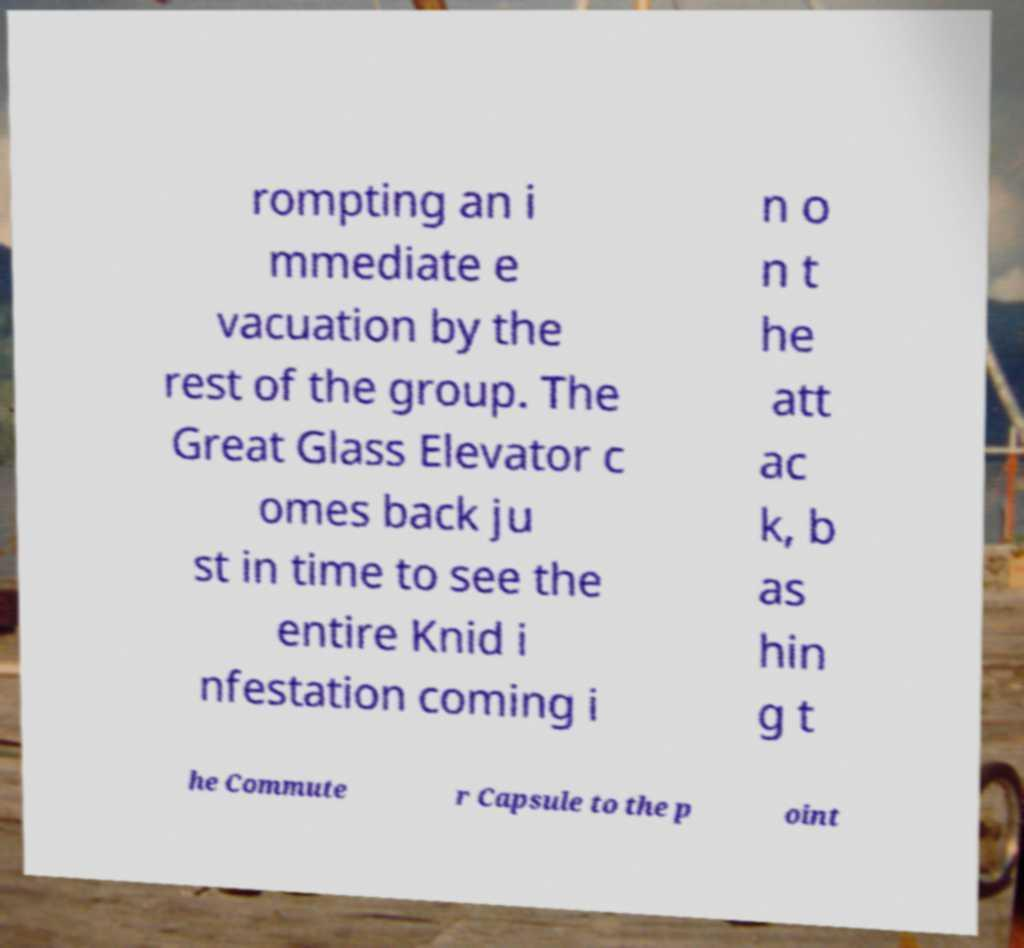What messages or text are displayed in this image? I need them in a readable, typed format. rompting an i mmediate e vacuation by the rest of the group. The Great Glass Elevator c omes back ju st in time to see the entire Knid i nfestation coming i n o n t he att ac k, b as hin g t he Commute r Capsule to the p oint 